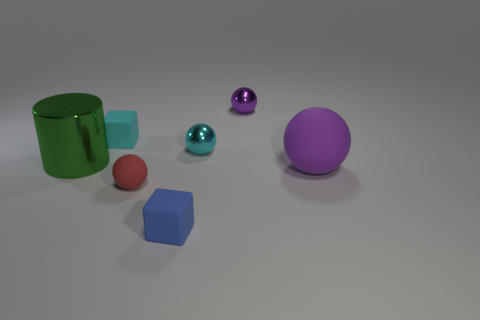What is the color of the small matte thing that is behind the small blue matte cube and in front of the big purple rubber thing?
Give a very brief answer. Red. Are there any purple objects of the same size as the blue cube?
Keep it short and to the point. Yes. There is a purple sphere that is in front of the cyan thing that is on the left side of the tiny blue cube; what is its size?
Your answer should be compact. Large. Is the number of big matte balls that are behind the large sphere less than the number of big balls?
Provide a succinct answer. Yes. Does the big cylinder have the same color as the large ball?
Your response must be concise. No. The cyan shiny thing has what size?
Keep it short and to the point. Small. What number of other metal objects are the same color as the big shiny object?
Offer a very short reply. 0. Is there a tiny cyan shiny ball left of the tiny rubber thing that is behind the purple sphere in front of the tiny purple metal object?
Give a very brief answer. No. There is a purple object that is the same size as the green cylinder; what is its shape?
Provide a short and direct response. Sphere. What number of small objects are either green balls or shiny objects?
Give a very brief answer. 2. 